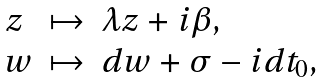Convert formula to latex. <formula><loc_0><loc_0><loc_500><loc_500>\begin{array} { l l l } z & \mapsto & \lambda z + i \beta , \\ w & \mapsto & d w + \sigma - i d t _ { 0 } , \end{array}</formula> 